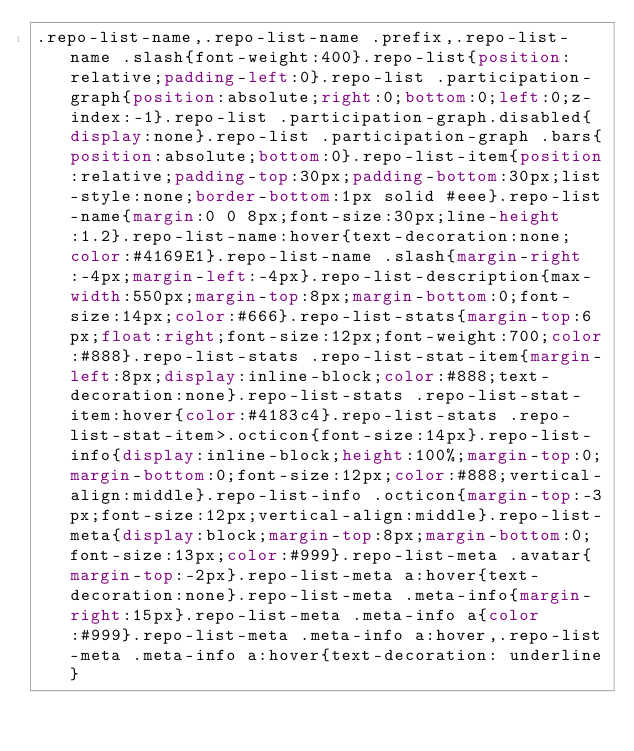Convert code to text. <code><loc_0><loc_0><loc_500><loc_500><_CSS_>.repo-list-name,.repo-list-name .prefix,.repo-list-name .slash{font-weight:400}.repo-list{position:relative;padding-left:0}.repo-list .participation-graph{position:absolute;right:0;bottom:0;left:0;z-index:-1}.repo-list .participation-graph.disabled{display:none}.repo-list .participation-graph .bars{position:absolute;bottom:0}.repo-list-item{position:relative;padding-top:30px;padding-bottom:30px;list-style:none;border-bottom:1px solid #eee}.repo-list-name{margin:0 0 8px;font-size:30px;line-height:1.2}.repo-list-name:hover{text-decoration:none;color:#4169E1}.repo-list-name .slash{margin-right:-4px;margin-left:-4px}.repo-list-description{max-width:550px;margin-top:8px;margin-bottom:0;font-size:14px;color:#666}.repo-list-stats{margin-top:6px;float:right;font-size:12px;font-weight:700;color:#888}.repo-list-stats .repo-list-stat-item{margin-left:8px;display:inline-block;color:#888;text-decoration:none}.repo-list-stats .repo-list-stat-item:hover{color:#4183c4}.repo-list-stats .repo-list-stat-item>.octicon{font-size:14px}.repo-list-info{display:inline-block;height:100%;margin-top:0;margin-bottom:0;font-size:12px;color:#888;vertical-align:middle}.repo-list-info .octicon{margin-top:-3px;font-size:12px;vertical-align:middle}.repo-list-meta{display:block;margin-top:8px;margin-bottom:0;font-size:13px;color:#999}.repo-list-meta .avatar{margin-top:-2px}.repo-list-meta a:hover{text-decoration:none}.repo-list-meta .meta-info{margin-right:15px}.repo-list-meta .meta-info a{color:#999}.repo-list-meta .meta-info a:hover,.repo-list-meta .meta-info a:hover{text-decoration: underline}
</code> 